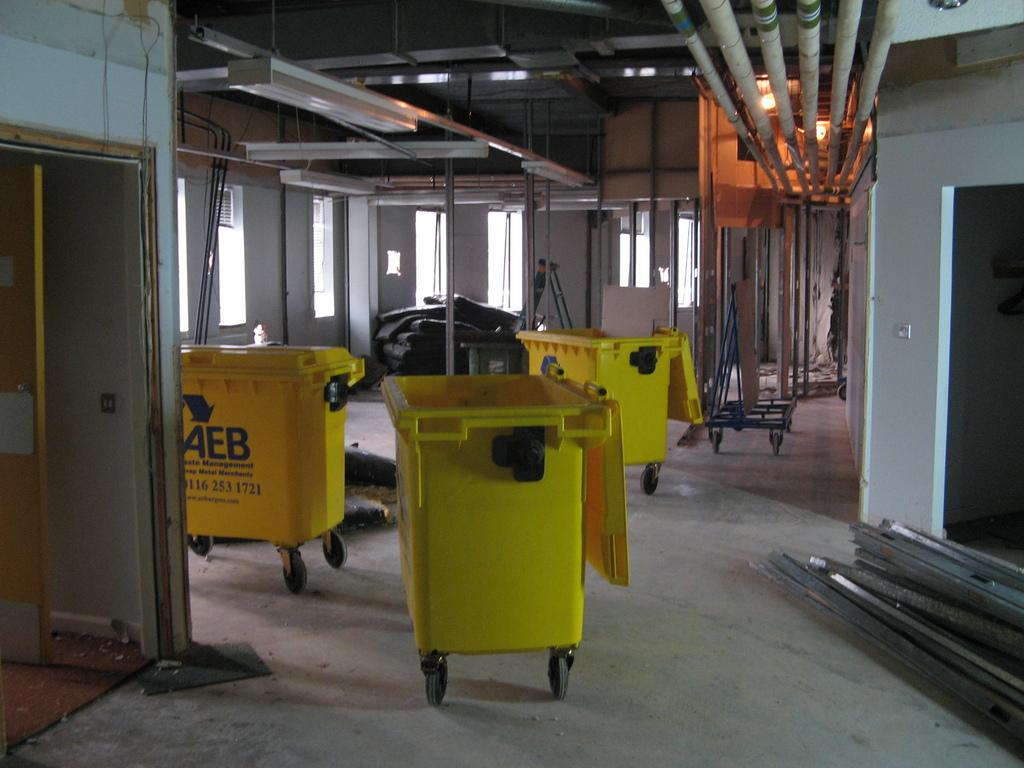What is the brand of container?
Give a very brief answer. Aeb. 